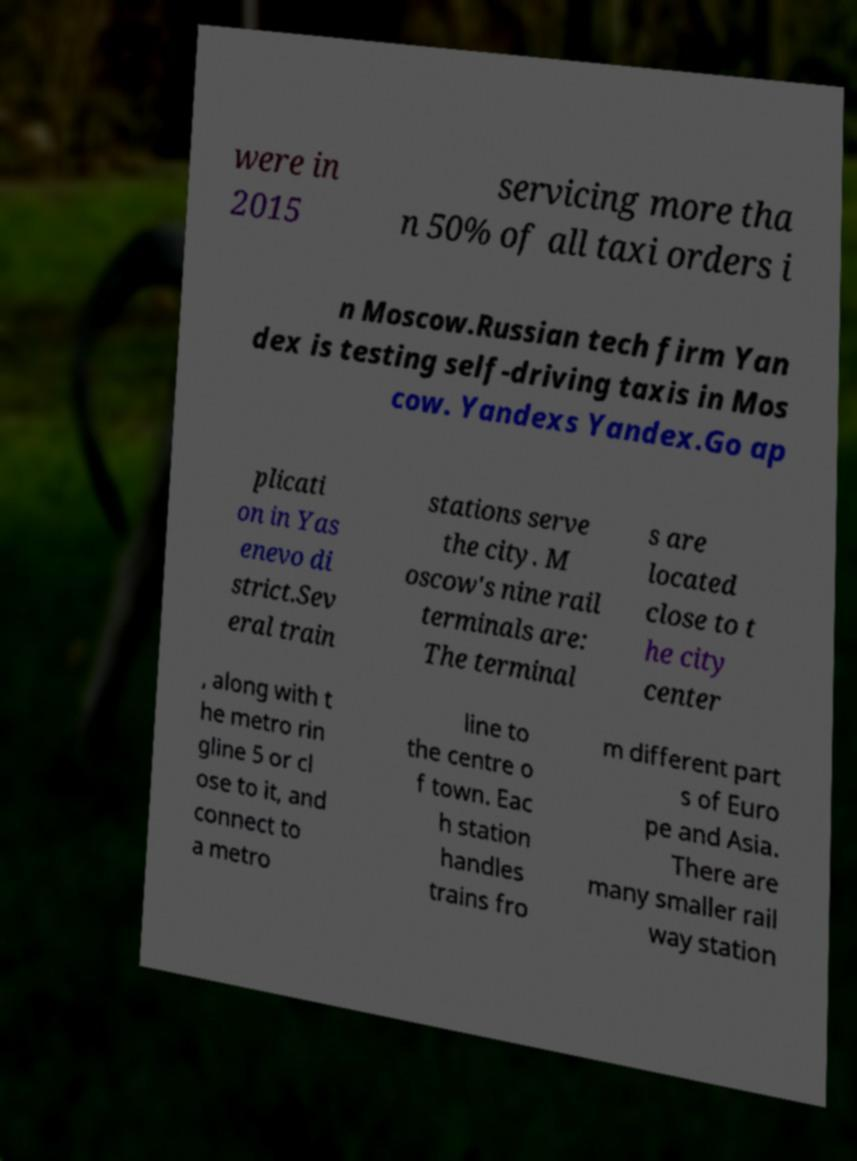Can you accurately transcribe the text from the provided image for me? were in 2015 servicing more tha n 50% of all taxi orders i n Moscow.Russian tech firm Yan dex is testing self-driving taxis in Mos cow. Yandexs Yandex.Go ap plicati on in Yas enevo di strict.Sev eral train stations serve the city. M oscow's nine rail terminals are: The terminal s are located close to t he city center , along with t he metro rin gline 5 or cl ose to it, and connect to a metro line to the centre o f town. Eac h station handles trains fro m different part s of Euro pe and Asia. There are many smaller rail way station 